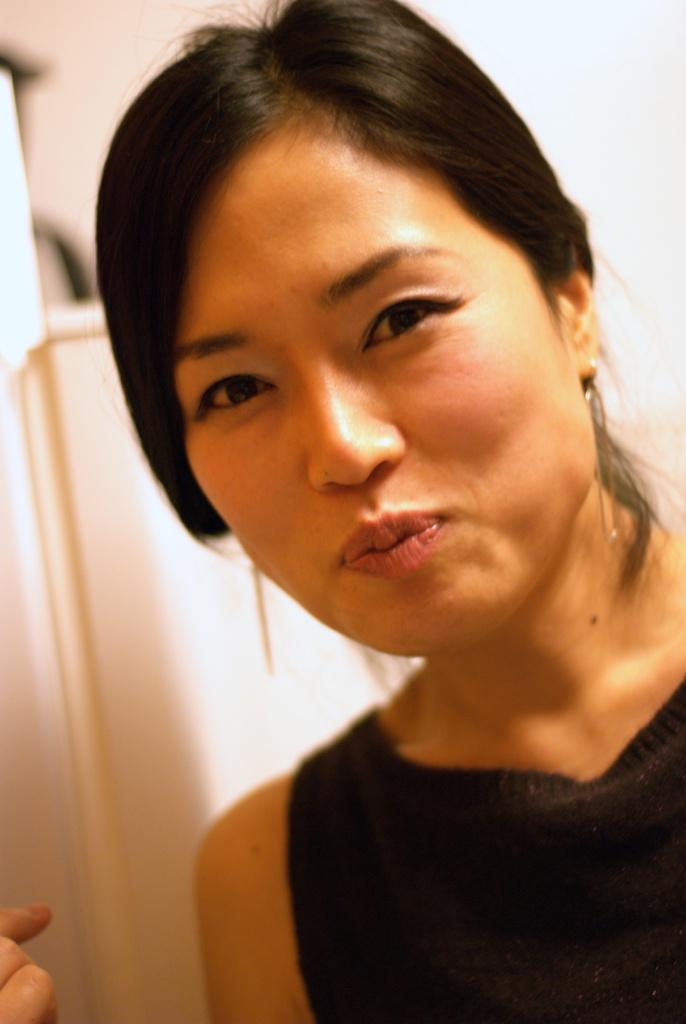Who is the main subject in the image? There is a woman in the image. What is the woman wearing? The woman is wearing a black dress. What is the woman's facial expression? The woman is smiling. What color is the background of the image? The background of the image is white. How much wealth does the woman have in the image? There is no indication of the woman's wealth in the image. 